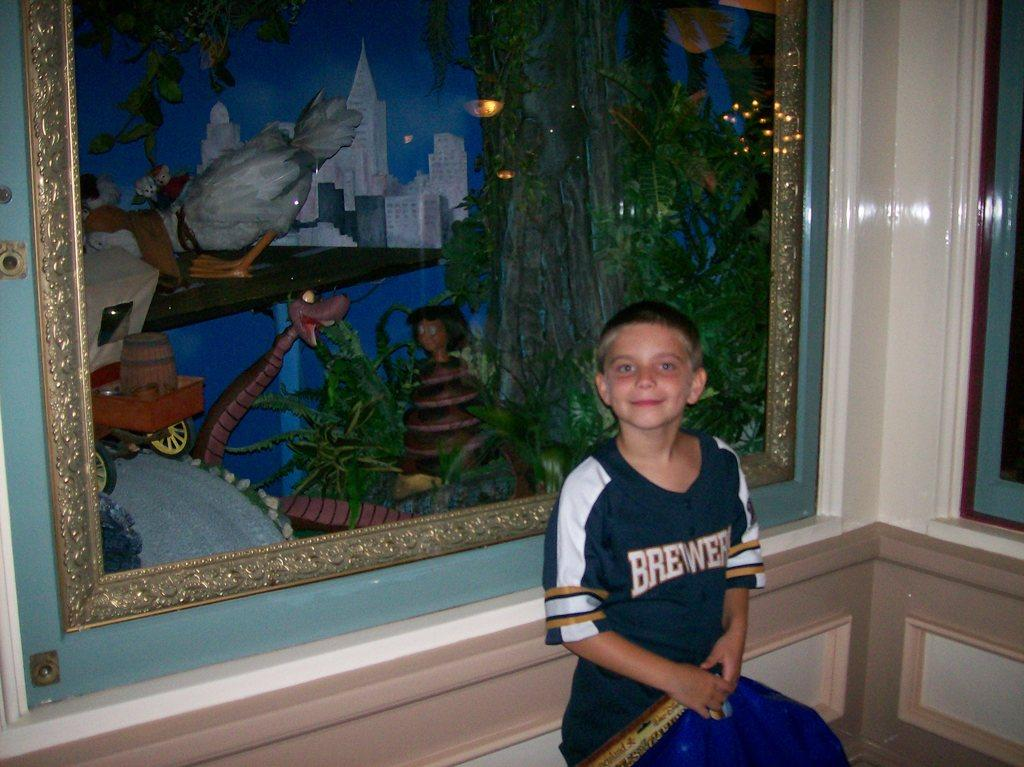<image>
Give a short and clear explanation of the subsequent image. A small child sitting next to a framed painting while wearing a brewers shirt. 